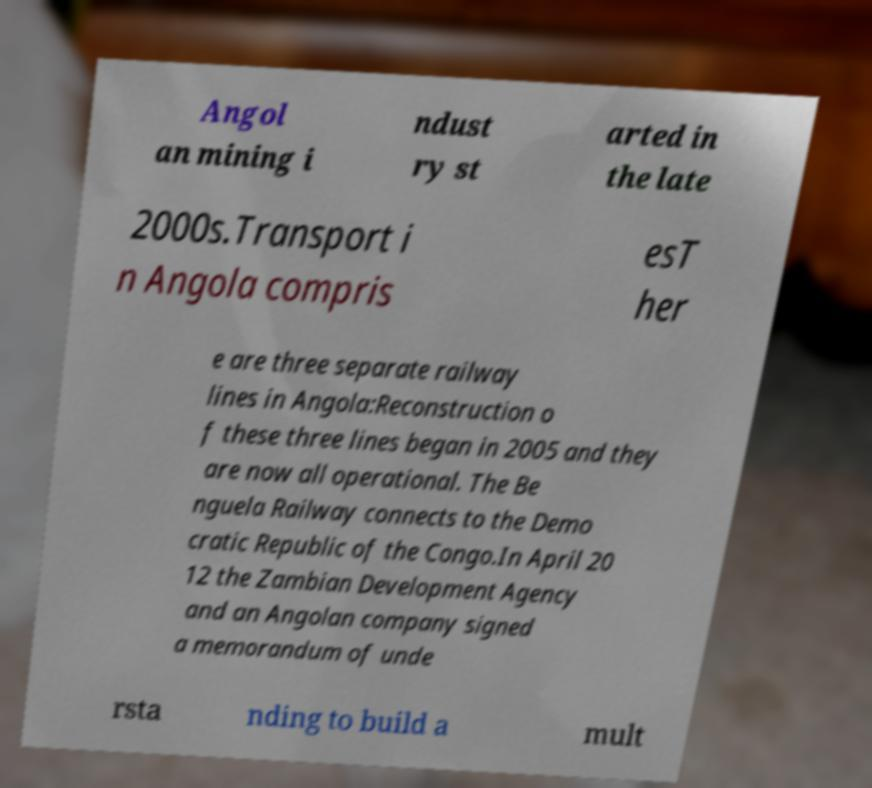What messages or text are displayed in this image? I need them in a readable, typed format. Angol an mining i ndust ry st arted in the late 2000s.Transport i n Angola compris esT her e are three separate railway lines in Angola:Reconstruction o f these three lines began in 2005 and they are now all operational. The Be nguela Railway connects to the Demo cratic Republic of the Congo.In April 20 12 the Zambian Development Agency and an Angolan company signed a memorandum of unde rsta nding to build a mult 